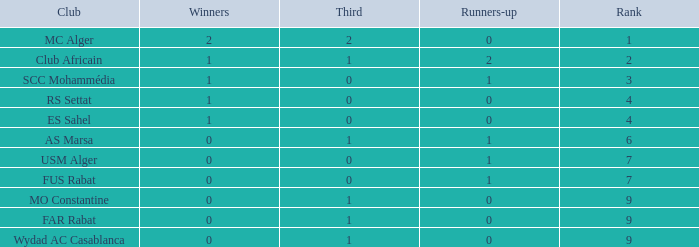How many Winners have a Third of 1, and Runners-up smaller than 0? 0.0. 